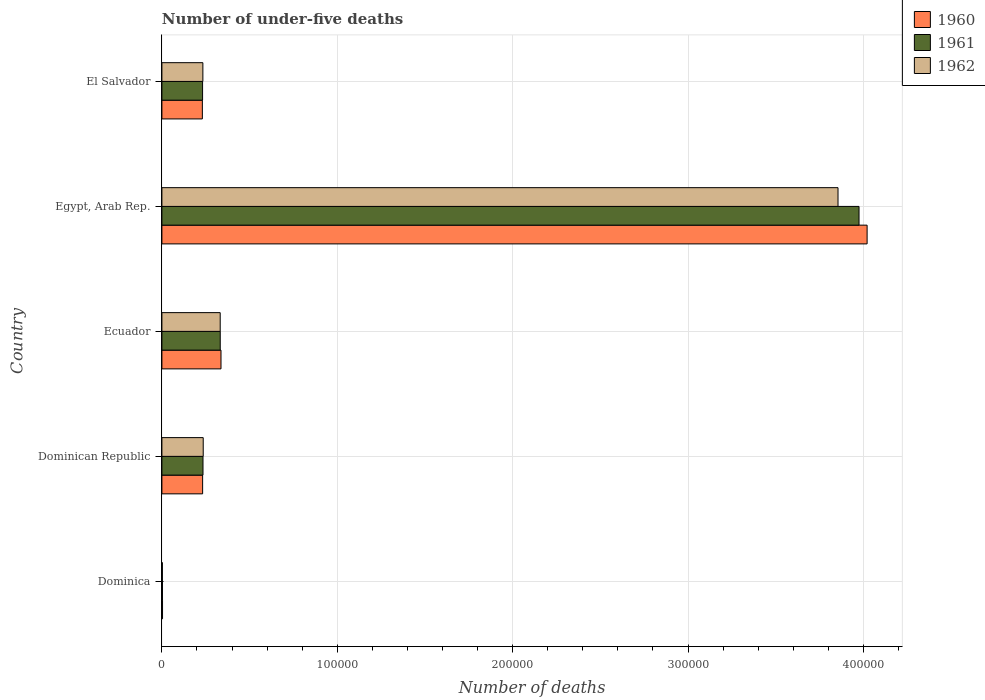How many groups of bars are there?
Your response must be concise. 5. Are the number of bars on each tick of the Y-axis equal?
Your answer should be very brief. Yes. What is the label of the 1st group of bars from the top?
Provide a succinct answer. El Salvador. What is the number of under-five deaths in 1960 in Egypt, Arab Rep.?
Offer a very short reply. 4.02e+05. Across all countries, what is the maximum number of under-five deaths in 1961?
Your answer should be very brief. 3.98e+05. Across all countries, what is the minimum number of under-five deaths in 1960?
Provide a short and direct response. 362. In which country was the number of under-five deaths in 1962 maximum?
Offer a terse response. Egypt, Arab Rep. In which country was the number of under-five deaths in 1960 minimum?
Keep it short and to the point. Dominica. What is the total number of under-five deaths in 1960 in the graph?
Provide a succinct answer. 4.82e+05. What is the difference between the number of under-five deaths in 1960 in Dominica and that in Ecuador?
Your answer should be compact. -3.33e+04. What is the difference between the number of under-five deaths in 1962 in Dominica and the number of under-five deaths in 1961 in Dominican Republic?
Offer a terse response. -2.32e+04. What is the average number of under-five deaths in 1960 per country?
Offer a very short reply. 9.65e+04. What is the difference between the number of under-five deaths in 1962 and number of under-five deaths in 1961 in Dominica?
Your response must be concise. -46. What is the ratio of the number of under-five deaths in 1960 in Ecuador to that in Egypt, Arab Rep.?
Keep it short and to the point. 0.08. Is the difference between the number of under-five deaths in 1962 in Ecuador and Egypt, Arab Rep. greater than the difference between the number of under-five deaths in 1961 in Ecuador and Egypt, Arab Rep.?
Provide a short and direct response. Yes. What is the difference between the highest and the second highest number of under-five deaths in 1960?
Your answer should be very brief. 3.68e+05. What is the difference between the highest and the lowest number of under-five deaths in 1961?
Keep it short and to the point. 3.97e+05. In how many countries, is the number of under-five deaths in 1961 greater than the average number of under-five deaths in 1961 taken over all countries?
Your answer should be very brief. 1. How many bars are there?
Your answer should be compact. 15. How many countries are there in the graph?
Your answer should be compact. 5. What is the difference between two consecutive major ticks on the X-axis?
Make the answer very short. 1.00e+05. Does the graph contain grids?
Give a very brief answer. Yes. Where does the legend appear in the graph?
Provide a succinct answer. Top right. What is the title of the graph?
Offer a terse response. Number of under-five deaths. What is the label or title of the X-axis?
Provide a short and direct response. Number of deaths. What is the Number of deaths in 1960 in Dominica?
Offer a terse response. 362. What is the Number of deaths of 1961 in Dominica?
Keep it short and to the point. 324. What is the Number of deaths in 1962 in Dominica?
Your response must be concise. 278. What is the Number of deaths of 1960 in Dominican Republic?
Your answer should be very brief. 2.32e+04. What is the Number of deaths in 1961 in Dominican Republic?
Your response must be concise. 2.34e+04. What is the Number of deaths in 1962 in Dominican Republic?
Keep it short and to the point. 2.36e+04. What is the Number of deaths of 1960 in Ecuador?
Your answer should be very brief. 3.37e+04. What is the Number of deaths of 1961 in Ecuador?
Keep it short and to the point. 3.33e+04. What is the Number of deaths of 1962 in Ecuador?
Offer a very short reply. 3.32e+04. What is the Number of deaths of 1960 in Egypt, Arab Rep.?
Keep it short and to the point. 4.02e+05. What is the Number of deaths in 1961 in Egypt, Arab Rep.?
Provide a short and direct response. 3.98e+05. What is the Number of deaths of 1962 in Egypt, Arab Rep.?
Make the answer very short. 3.86e+05. What is the Number of deaths of 1960 in El Salvador?
Keep it short and to the point. 2.31e+04. What is the Number of deaths in 1961 in El Salvador?
Make the answer very short. 2.32e+04. What is the Number of deaths in 1962 in El Salvador?
Your answer should be compact. 2.34e+04. Across all countries, what is the maximum Number of deaths of 1960?
Make the answer very short. 4.02e+05. Across all countries, what is the maximum Number of deaths of 1961?
Keep it short and to the point. 3.98e+05. Across all countries, what is the maximum Number of deaths of 1962?
Offer a very short reply. 3.86e+05. Across all countries, what is the minimum Number of deaths in 1960?
Ensure brevity in your answer.  362. Across all countries, what is the minimum Number of deaths in 1961?
Provide a short and direct response. 324. Across all countries, what is the minimum Number of deaths in 1962?
Your answer should be compact. 278. What is the total Number of deaths of 1960 in the graph?
Your answer should be very brief. 4.82e+05. What is the total Number of deaths of 1961 in the graph?
Keep it short and to the point. 4.78e+05. What is the total Number of deaths in 1962 in the graph?
Your response must be concise. 4.66e+05. What is the difference between the Number of deaths in 1960 in Dominica and that in Dominican Republic?
Offer a very short reply. -2.29e+04. What is the difference between the Number of deaths in 1961 in Dominica and that in Dominican Republic?
Your answer should be very brief. -2.31e+04. What is the difference between the Number of deaths of 1962 in Dominica and that in Dominican Republic?
Provide a short and direct response. -2.33e+04. What is the difference between the Number of deaths of 1960 in Dominica and that in Ecuador?
Give a very brief answer. -3.33e+04. What is the difference between the Number of deaths in 1961 in Dominica and that in Ecuador?
Your answer should be compact. -3.29e+04. What is the difference between the Number of deaths of 1962 in Dominica and that in Ecuador?
Offer a terse response. -3.30e+04. What is the difference between the Number of deaths of 1960 in Dominica and that in Egypt, Arab Rep.?
Keep it short and to the point. -4.02e+05. What is the difference between the Number of deaths in 1961 in Dominica and that in Egypt, Arab Rep.?
Keep it short and to the point. -3.97e+05. What is the difference between the Number of deaths in 1962 in Dominica and that in Egypt, Arab Rep.?
Give a very brief answer. -3.85e+05. What is the difference between the Number of deaths in 1960 in Dominica and that in El Salvador?
Your answer should be compact. -2.27e+04. What is the difference between the Number of deaths of 1961 in Dominica and that in El Salvador?
Provide a succinct answer. -2.29e+04. What is the difference between the Number of deaths in 1962 in Dominica and that in El Salvador?
Keep it short and to the point. -2.31e+04. What is the difference between the Number of deaths of 1960 in Dominican Republic and that in Ecuador?
Offer a very short reply. -1.05e+04. What is the difference between the Number of deaths of 1961 in Dominican Republic and that in Ecuador?
Give a very brief answer. -9834. What is the difference between the Number of deaths in 1962 in Dominican Republic and that in Ecuador?
Offer a very short reply. -9677. What is the difference between the Number of deaths in 1960 in Dominican Republic and that in Egypt, Arab Rep.?
Keep it short and to the point. -3.79e+05. What is the difference between the Number of deaths of 1961 in Dominican Republic and that in Egypt, Arab Rep.?
Your response must be concise. -3.74e+05. What is the difference between the Number of deaths of 1962 in Dominican Republic and that in Egypt, Arab Rep.?
Provide a succinct answer. -3.62e+05. What is the difference between the Number of deaths in 1960 in Dominican Republic and that in El Salvador?
Ensure brevity in your answer.  145. What is the difference between the Number of deaths of 1961 in Dominican Republic and that in El Salvador?
Keep it short and to the point. 241. What is the difference between the Number of deaths of 1962 in Dominican Republic and that in El Salvador?
Your answer should be compact. 198. What is the difference between the Number of deaths of 1960 in Ecuador and that in Egypt, Arab Rep.?
Offer a very short reply. -3.68e+05. What is the difference between the Number of deaths of 1961 in Ecuador and that in Egypt, Arab Rep.?
Your response must be concise. -3.64e+05. What is the difference between the Number of deaths of 1962 in Ecuador and that in Egypt, Arab Rep.?
Give a very brief answer. -3.52e+05. What is the difference between the Number of deaths in 1960 in Ecuador and that in El Salvador?
Ensure brevity in your answer.  1.06e+04. What is the difference between the Number of deaths of 1961 in Ecuador and that in El Salvador?
Ensure brevity in your answer.  1.01e+04. What is the difference between the Number of deaths of 1962 in Ecuador and that in El Salvador?
Provide a short and direct response. 9875. What is the difference between the Number of deaths in 1960 in Egypt, Arab Rep. and that in El Salvador?
Keep it short and to the point. 3.79e+05. What is the difference between the Number of deaths of 1961 in Egypt, Arab Rep. and that in El Salvador?
Your answer should be compact. 3.74e+05. What is the difference between the Number of deaths in 1962 in Egypt, Arab Rep. and that in El Salvador?
Keep it short and to the point. 3.62e+05. What is the difference between the Number of deaths of 1960 in Dominica and the Number of deaths of 1961 in Dominican Republic?
Provide a short and direct response. -2.31e+04. What is the difference between the Number of deaths in 1960 in Dominica and the Number of deaths in 1962 in Dominican Republic?
Keep it short and to the point. -2.32e+04. What is the difference between the Number of deaths of 1961 in Dominica and the Number of deaths of 1962 in Dominican Republic?
Ensure brevity in your answer.  -2.32e+04. What is the difference between the Number of deaths of 1960 in Dominica and the Number of deaths of 1961 in Ecuador?
Offer a terse response. -3.29e+04. What is the difference between the Number of deaths in 1960 in Dominica and the Number of deaths in 1962 in Ecuador?
Give a very brief answer. -3.29e+04. What is the difference between the Number of deaths in 1961 in Dominica and the Number of deaths in 1962 in Ecuador?
Your answer should be very brief. -3.29e+04. What is the difference between the Number of deaths of 1960 in Dominica and the Number of deaths of 1961 in Egypt, Arab Rep.?
Your answer should be very brief. -3.97e+05. What is the difference between the Number of deaths of 1960 in Dominica and the Number of deaths of 1962 in Egypt, Arab Rep.?
Make the answer very short. -3.85e+05. What is the difference between the Number of deaths in 1961 in Dominica and the Number of deaths in 1962 in Egypt, Arab Rep.?
Offer a terse response. -3.85e+05. What is the difference between the Number of deaths in 1960 in Dominica and the Number of deaths in 1961 in El Salvador?
Keep it short and to the point. -2.28e+04. What is the difference between the Number of deaths of 1960 in Dominica and the Number of deaths of 1962 in El Salvador?
Make the answer very short. -2.30e+04. What is the difference between the Number of deaths of 1961 in Dominica and the Number of deaths of 1962 in El Salvador?
Your answer should be very brief. -2.30e+04. What is the difference between the Number of deaths in 1960 in Dominican Republic and the Number of deaths in 1961 in Ecuador?
Provide a succinct answer. -1.00e+04. What is the difference between the Number of deaths of 1960 in Dominican Republic and the Number of deaths of 1962 in Ecuador?
Give a very brief answer. -1.00e+04. What is the difference between the Number of deaths in 1961 in Dominican Republic and the Number of deaths in 1962 in Ecuador?
Provide a succinct answer. -9809. What is the difference between the Number of deaths of 1960 in Dominican Republic and the Number of deaths of 1961 in Egypt, Arab Rep.?
Ensure brevity in your answer.  -3.74e+05. What is the difference between the Number of deaths of 1960 in Dominican Republic and the Number of deaths of 1962 in Egypt, Arab Rep.?
Offer a terse response. -3.62e+05. What is the difference between the Number of deaths in 1961 in Dominican Republic and the Number of deaths in 1962 in Egypt, Arab Rep.?
Your answer should be very brief. -3.62e+05. What is the difference between the Number of deaths in 1960 in Dominican Republic and the Number of deaths in 1961 in El Salvador?
Offer a very short reply. 27. What is the difference between the Number of deaths in 1960 in Dominican Republic and the Number of deaths in 1962 in El Salvador?
Make the answer very short. -148. What is the difference between the Number of deaths in 1961 in Dominican Republic and the Number of deaths in 1962 in El Salvador?
Ensure brevity in your answer.  66. What is the difference between the Number of deaths in 1960 in Ecuador and the Number of deaths in 1961 in Egypt, Arab Rep.?
Your answer should be compact. -3.64e+05. What is the difference between the Number of deaths in 1960 in Ecuador and the Number of deaths in 1962 in Egypt, Arab Rep.?
Your answer should be compact. -3.52e+05. What is the difference between the Number of deaths in 1961 in Ecuador and the Number of deaths in 1962 in Egypt, Arab Rep.?
Keep it short and to the point. -3.52e+05. What is the difference between the Number of deaths of 1960 in Ecuador and the Number of deaths of 1961 in El Salvador?
Your response must be concise. 1.05e+04. What is the difference between the Number of deaths in 1960 in Ecuador and the Number of deaths in 1962 in El Salvador?
Your response must be concise. 1.03e+04. What is the difference between the Number of deaths of 1961 in Ecuador and the Number of deaths of 1962 in El Salvador?
Keep it short and to the point. 9900. What is the difference between the Number of deaths of 1960 in Egypt, Arab Rep. and the Number of deaths of 1961 in El Salvador?
Your response must be concise. 3.79e+05. What is the difference between the Number of deaths of 1960 in Egypt, Arab Rep. and the Number of deaths of 1962 in El Salvador?
Make the answer very short. 3.79e+05. What is the difference between the Number of deaths in 1961 in Egypt, Arab Rep. and the Number of deaths in 1962 in El Salvador?
Keep it short and to the point. 3.74e+05. What is the average Number of deaths in 1960 per country?
Provide a succinct answer. 9.65e+04. What is the average Number of deaths in 1961 per country?
Make the answer very short. 9.55e+04. What is the average Number of deaths in 1962 per country?
Give a very brief answer. 9.32e+04. What is the difference between the Number of deaths of 1960 and Number of deaths of 1962 in Dominica?
Provide a short and direct response. 84. What is the difference between the Number of deaths of 1960 and Number of deaths of 1961 in Dominican Republic?
Your response must be concise. -214. What is the difference between the Number of deaths in 1960 and Number of deaths in 1962 in Dominican Republic?
Provide a succinct answer. -346. What is the difference between the Number of deaths in 1961 and Number of deaths in 1962 in Dominican Republic?
Give a very brief answer. -132. What is the difference between the Number of deaths of 1960 and Number of deaths of 1961 in Ecuador?
Offer a very short reply. 433. What is the difference between the Number of deaths in 1960 and Number of deaths in 1962 in Ecuador?
Offer a very short reply. 458. What is the difference between the Number of deaths in 1961 and Number of deaths in 1962 in Ecuador?
Your response must be concise. 25. What is the difference between the Number of deaths in 1960 and Number of deaths in 1961 in Egypt, Arab Rep.?
Offer a terse response. 4607. What is the difference between the Number of deaths of 1960 and Number of deaths of 1962 in Egypt, Arab Rep.?
Ensure brevity in your answer.  1.66e+04. What is the difference between the Number of deaths of 1961 and Number of deaths of 1962 in Egypt, Arab Rep.?
Your answer should be very brief. 1.20e+04. What is the difference between the Number of deaths in 1960 and Number of deaths in 1961 in El Salvador?
Ensure brevity in your answer.  -118. What is the difference between the Number of deaths in 1960 and Number of deaths in 1962 in El Salvador?
Offer a terse response. -293. What is the difference between the Number of deaths in 1961 and Number of deaths in 1962 in El Salvador?
Provide a succinct answer. -175. What is the ratio of the Number of deaths in 1960 in Dominica to that in Dominican Republic?
Give a very brief answer. 0.02. What is the ratio of the Number of deaths of 1961 in Dominica to that in Dominican Republic?
Provide a short and direct response. 0.01. What is the ratio of the Number of deaths of 1962 in Dominica to that in Dominican Republic?
Your response must be concise. 0.01. What is the ratio of the Number of deaths of 1960 in Dominica to that in Ecuador?
Keep it short and to the point. 0.01. What is the ratio of the Number of deaths of 1961 in Dominica to that in Ecuador?
Give a very brief answer. 0.01. What is the ratio of the Number of deaths in 1962 in Dominica to that in Ecuador?
Your response must be concise. 0.01. What is the ratio of the Number of deaths of 1960 in Dominica to that in Egypt, Arab Rep.?
Your answer should be very brief. 0. What is the ratio of the Number of deaths of 1961 in Dominica to that in Egypt, Arab Rep.?
Your response must be concise. 0. What is the ratio of the Number of deaths of 1962 in Dominica to that in Egypt, Arab Rep.?
Make the answer very short. 0. What is the ratio of the Number of deaths of 1960 in Dominica to that in El Salvador?
Ensure brevity in your answer.  0.02. What is the ratio of the Number of deaths in 1961 in Dominica to that in El Salvador?
Make the answer very short. 0.01. What is the ratio of the Number of deaths of 1962 in Dominica to that in El Salvador?
Offer a terse response. 0.01. What is the ratio of the Number of deaths in 1960 in Dominican Republic to that in Ecuador?
Provide a succinct answer. 0.69. What is the ratio of the Number of deaths in 1961 in Dominican Republic to that in Ecuador?
Your answer should be very brief. 0.7. What is the ratio of the Number of deaths of 1962 in Dominican Republic to that in Ecuador?
Your answer should be compact. 0.71. What is the ratio of the Number of deaths of 1960 in Dominican Republic to that in Egypt, Arab Rep.?
Offer a very short reply. 0.06. What is the ratio of the Number of deaths in 1961 in Dominican Republic to that in Egypt, Arab Rep.?
Provide a succinct answer. 0.06. What is the ratio of the Number of deaths of 1962 in Dominican Republic to that in Egypt, Arab Rep.?
Your response must be concise. 0.06. What is the ratio of the Number of deaths in 1961 in Dominican Republic to that in El Salvador?
Provide a short and direct response. 1.01. What is the ratio of the Number of deaths in 1962 in Dominican Republic to that in El Salvador?
Offer a very short reply. 1.01. What is the ratio of the Number of deaths in 1960 in Ecuador to that in Egypt, Arab Rep.?
Give a very brief answer. 0.08. What is the ratio of the Number of deaths in 1961 in Ecuador to that in Egypt, Arab Rep.?
Your response must be concise. 0.08. What is the ratio of the Number of deaths of 1962 in Ecuador to that in Egypt, Arab Rep.?
Make the answer very short. 0.09. What is the ratio of the Number of deaths of 1960 in Ecuador to that in El Salvador?
Offer a very short reply. 1.46. What is the ratio of the Number of deaths in 1961 in Ecuador to that in El Salvador?
Make the answer very short. 1.43. What is the ratio of the Number of deaths in 1962 in Ecuador to that in El Salvador?
Provide a succinct answer. 1.42. What is the ratio of the Number of deaths of 1960 in Egypt, Arab Rep. to that in El Salvador?
Ensure brevity in your answer.  17.43. What is the ratio of the Number of deaths in 1961 in Egypt, Arab Rep. to that in El Salvador?
Provide a short and direct response. 17.14. What is the ratio of the Number of deaths in 1962 in Egypt, Arab Rep. to that in El Salvador?
Offer a terse response. 16.5. What is the difference between the highest and the second highest Number of deaths of 1960?
Give a very brief answer. 3.68e+05. What is the difference between the highest and the second highest Number of deaths in 1961?
Offer a very short reply. 3.64e+05. What is the difference between the highest and the second highest Number of deaths of 1962?
Offer a very short reply. 3.52e+05. What is the difference between the highest and the lowest Number of deaths of 1960?
Your answer should be compact. 4.02e+05. What is the difference between the highest and the lowest Number of deaths of 1961?
Offer a very short reply. 3.97e+05. What is the difference between the highest and the lowest Number of deaths of 1962?
Provide a succinct answer. 3.85e+05. 